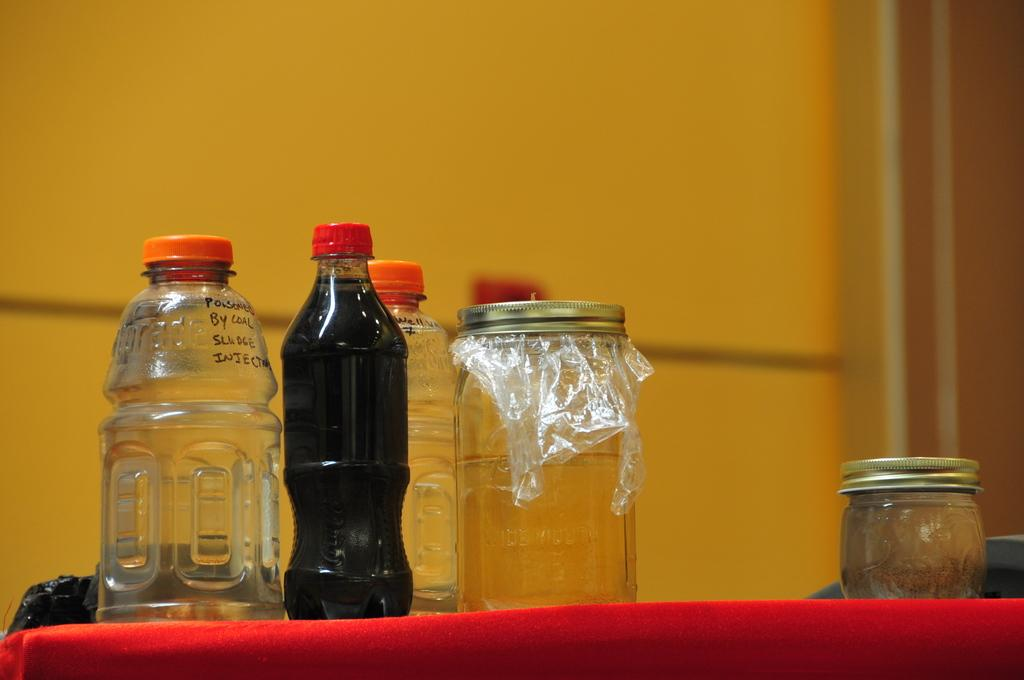<image>
Give a short and clear explanation of the subsequent image. An empty bottle with the words "poisoned by coal sludge injection" next to other bottles and jars. 